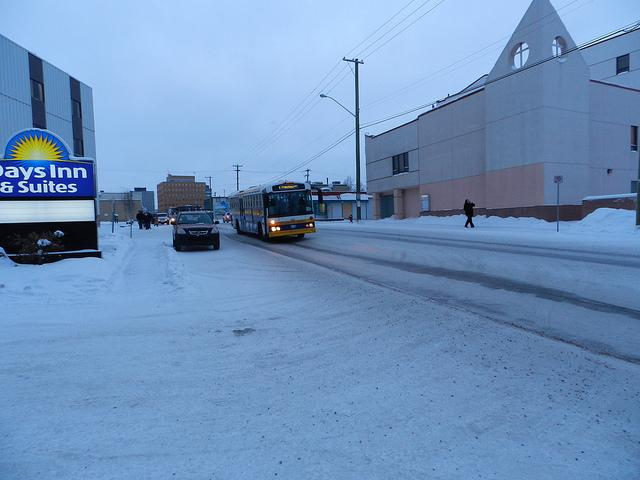What kind of building is the one with the sign on the left? Please explain your reasoning. hotel. The days inn & suites is a hotel business building. 